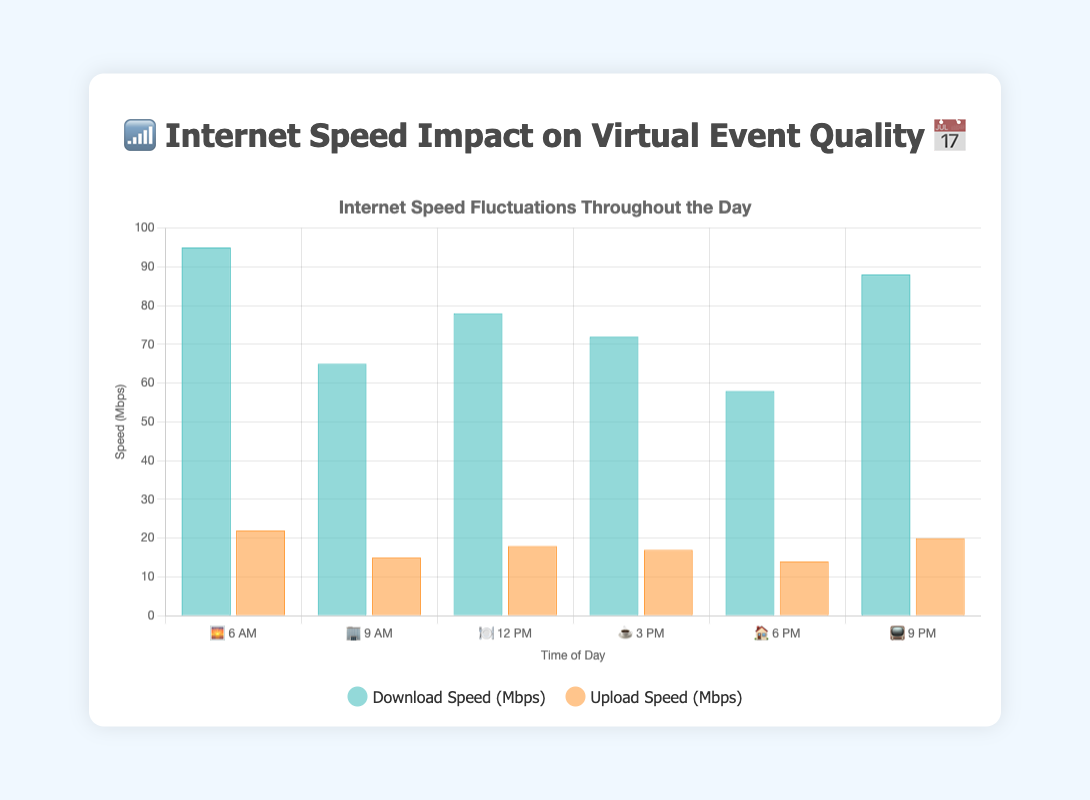What time of day has the highest download speed? Look at the bar corresponding to download speeds and identify the highest bar. The highest download speed is at 6 AM with 95 Mbps.
Answer: 6 AM What is the difference between download and upload speeds at 9 AM? At 9 AM, the download speed is 65 Mbps, and the upload speed is 15 Mbps. The difference is 65 - 15 = 50 Mbps.
Answer: 50 Mbps Which time period has the lowest upload speed? Identify the smallest bar among the upload speed bars. The upload speed is lowest at 6 PM with 14 Mbps.
Answer: 6 PM During which time periods is the event quality rated as ⭐⭐⭐? Find the times when the event quality rating is three stars. These times are 9 AM and 6 PM.
Answer: 9 AM, 6 PM What is the average download speed throughout the day? Sum up all the download speeds and divide by the number of time periods. The total download speed is 95 + 65 + 78 + 72 + 58 + 88 = 456 Mbps, and there are 6 time periods. So, the average download speed is 456 / 6 = 76 Mbps.
Answer: 76 Mbps How does the upload speed at 3 PM compare to the upload speed at 6 PM? At 3 PM, the upload speed is 17 Mbps, and at 6 PM, it is 14 Mbps. Comparing the two, 17 is greater than 14.
Answer: Higher at 3 PM What pattern can be observed about download speeds as the day progresses? Starting from 6 AM to 9 PM, observe the download speeds: 95, 65, 78, 72, 58, 88. Speeds fluctuate throughout the day without a clear increasing or decreasing trend.
Answer: Fluctuates Which time period has the highest event quality rating and what are the corresponding download and upload speeds? The highest event quality rating is five stars (⭐⭐⭐⭐⭐). These ratings occur at 6 AM and 9 PM. At 6 AM, the download/upload speeds are 95/22 Mbps, and at 9 PM, they are 88/20 Mbps.
Answer: 6 AM: 95/22 Mbps, 9 PM: 88/20 Mbps Does the evening (6 PM to 9 PM) download speed show improvement over the afternoon (12 PM to 3 PM) download speed? Compare the download speeds between 12 PM, 3 PM, 6 PM, and 9 PM. The speeds are 78, 72, 58, and 88 Mbps, respectively. The evening speeds (58, 88) do not consistently show improvement over the afternoon speeds (78, 72).
Answer: Not consistently During which time period do we observe the most significant drop in download speed? Identify the largest decrease between consecutive time periods. The download speed drops from 95 Mbps at 6 AM to 65 Mbps at 9 AM, a decrease of 30 Mbps.
Answer: 6 AM to 9 AM 